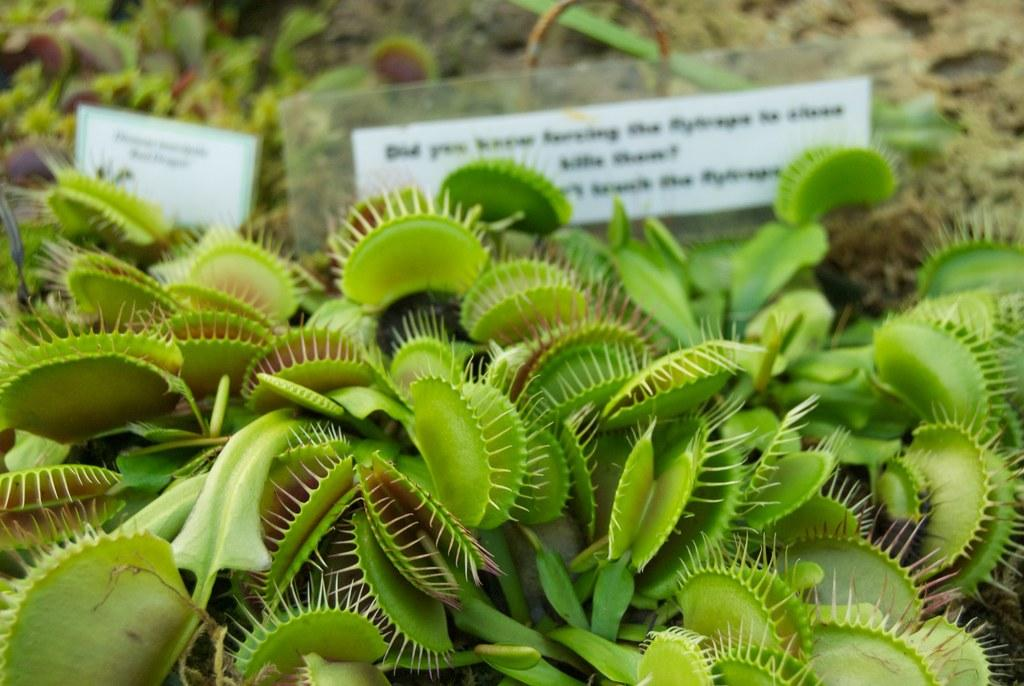What type of living organisms can be seen in the image? Plants can be seen in the image. What else is present in the image besides plants? There are text boards in the image. What type of mint can be seen growing on the text boards in the image? There is no mint visible in the image, and the text boards do not have any plants growing on them. 